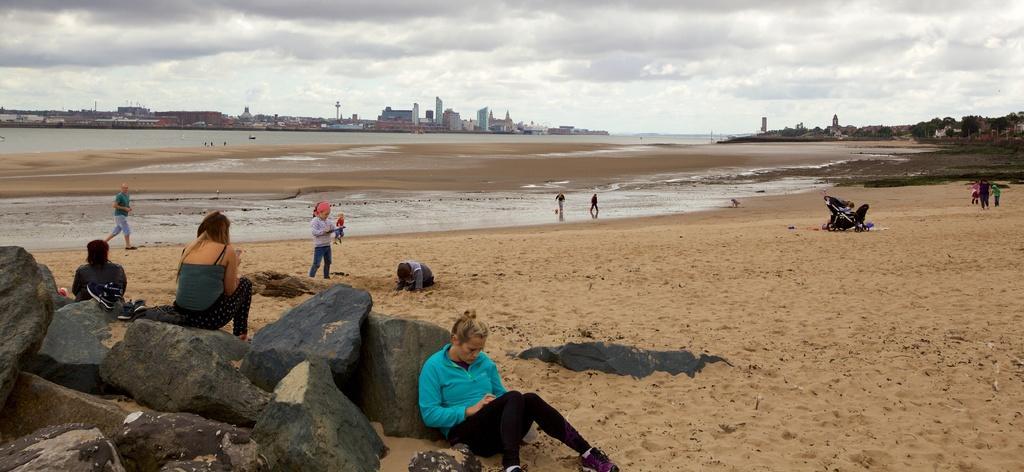How would you summarize this image in a sentence or two? In this image, we can see persons on beach. There are buildings in the middle of the image. There are rocks in the bottom left of the image. There are clouds in the sky. 